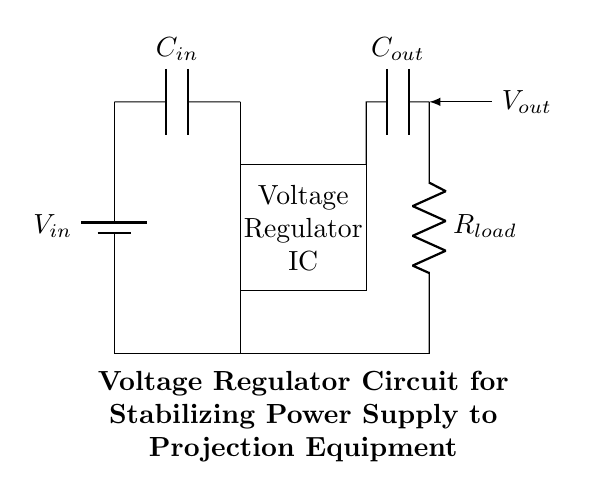What is the input voltage source labeled as? The input voltage source is labeled as V in, indicating the voltage level being provided to the circuit.
Answer: V in What components are used in this voltage regulator circuit? The components in this circuit include a battery (V in), an input capacitor (C in), a voltage regulator IC, an output capacitor (C out), and a load resistor (R load).
Answer: V in, C in, Voltage Regulator IC, C out, R load What does the output capacitor do in the circuit? The output capacitor (C out) smooths the output voltage, reducing ripple and providing stable voltage to the load.
Answer: Smoothes output voltage How does the voltage regulator affect V out? The voltage regulator maintains V out at a constant level, regardless of variations in V in or load conditions.
Answer: Maintains constant voltage Which component directly connects the load to the circuit's output? The load resistor, R load, connects directly to the output of the voltage regulator, allowing the current to flow to the load.
Answer: R load How is ground connected in the circuit? Ground is connected through the lower side of the battery (V in), the voltage regulator, and the output resistor (R load), creating a common reference point for the circuit.
Answer: Common reference point 